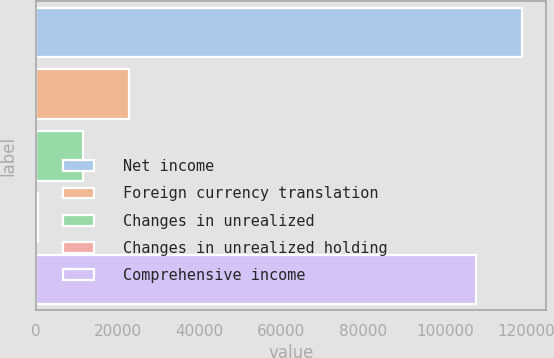Convert chart to OTSL. <chart><loc_0><loc_0><loc_500><loc_500><bar_chart><fcel>Net income<fcel>Foreign currency translation<fcel>Changes in unrealized<fcel>Changes in unrealized holding<fcel>Comprehensive income<nl><fcel>118829<fcel>22675.8<fcel>11559.9<fcel>444<fcel>107713<nl></chart> 